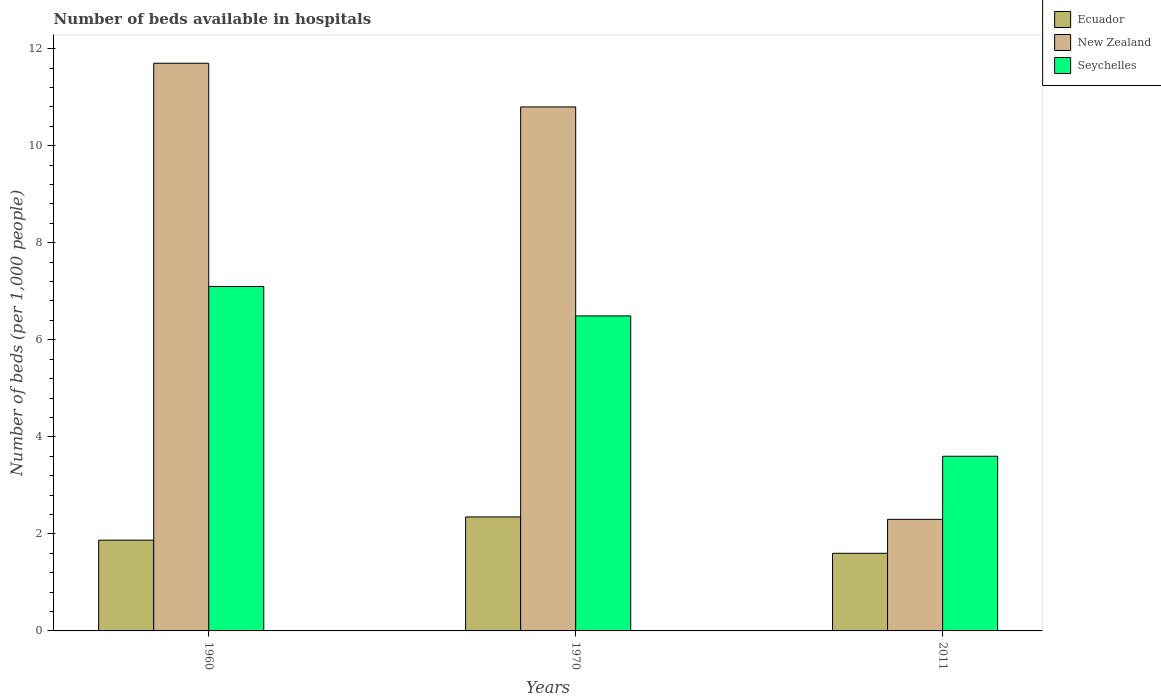How many different coloured bars are there?
Provide a short and direct response. 3. How many groups of bars are there?
Provide a succinct answer. 3. Are the number of bars per tick equal to the number of legend labels?
Provide a succinct answer. Yes. How many bars are there on the 1st tick from the left?
Your response must be concise. 3. How many bars are there on the 1st tick from the right?
Provide a succinct answer. 3. What is the label of the 1st group of bars from the left?
Offer a very short reply. 1960. What is the number of beds in the hospiatls of in New Zealand in 1960?
Give a very brief answer. 11.7. Across all years, what is the maximum number of beds in the hospiatls of in Ecuador?
Offer a very short reply. 2.35. Across all years, what is the minimum number of beds in the hospiatls of in New Zealand?
Your answer should be compact. 2.3. In which year was the number of beds in the hospiatls of in Ecuador maximum?
Provide a short and direct response. 1970. In which year was the number of beds in the hospiatls of in Seychelles minimum?
Provide a short and direct response. 2011. What is the total number of beds in the hospiatls of in Ecuador in the graph?
Provide a succinct answer. 5.82. What is the difference between the number of beds in the hospiatls of in Seychelles in 1960 and that in 2011?
Your answer should be very brief. 3.5. What is the difference between the number of beds in the hospiatls of in New Zealand in 2011 and the number of beds in the hospiatls of in Ecuador in 1960?
Provide a succinct answer. 0.43. What is the average number of beds in the hospiatls of in Ecuador per year?
Your answer should be compact. 1.94. In the year 1960, what is the difference between the number of beds in the hospiatls of in Ecuador and number of beds in the hospiatls of in Seychelles?
Provide a short and direct response. -5.23. What is the ratio of the number of beds in the hospiatls of in New Zealand in 1960 to that in 2011?
Ensure brevity in your answer.  5.09. Is the difference between the number of beds in the hospiatls of in Ecuador in 1960 and 2011 greater than the difference between the number of beds in the hospiatls of in Seychelles in 1960 and 2011?
Offer a terse response. No. What is the difference between the highest and the second highest number of beds in the hospiatls of in Ecuador?
Provide a short and direct response. 0.48. What is the difference between the highest and the lowest number of beds in the hospiatls of in New Zealand?
Your answer should be very brief. 9.4. What does the 2nd bar from the left in 1960 represents?
Ensure brevity in your answer.  New Zealand. What does the 3rd bar from the right in 1960 represents?
Your answer should be compact. Ecuador. Is it the case that in every year, the sum of the number of beds in the hospiatls of in Ecuador and number of beds in the hospiatls of in New Zealand is greater than the number of beds in the hospiatls of in Seychelles?
Offer a terse response. Yes. How many bars are there?
Give a very brief answer. 9. Are all the bars in the graph horizontal?
Your answer should be compact. No. What is the difference between two consecutive major ticks on the Y-axis?
Your response must be concise. 2. Are the values on the major ticks of Y-axis written in scientific E-notation?
Ensure brevity in your answer.  No. How many legend labels are there?
Offer a very short reply. 3. How are the legend labels stacked?
Ensure brevity in your answer.  Vertical. What is the title of the graph?
Ensure brevity in your answer.  Number of beds available in hospitals. What is the label or title of the X-axis?
Your response must be concise. Years. What is the label or title of the Y-axis?
Offer a very short reply. Number of beds (per 1,0 people). What is the Number of beds (per 1,000 people) in Ecuador in 1960?
Your answer should be compact. 1.87. What is the Number of beds (per 1,000 people) in New Zealand in 1960?
Provide a succinct answer. 11.7. What is the Number of beds (per 1,000 people) in Seychelles in 1960?
Offer a very short reply. 7.1. What is the Number of beds (per 1,000 people) of Ecuador in 1970?
Ensure brevity in your answer.  2.35. What is the Number of beds (per 1,000 people) in New Zealand in 1970?
Your answer should be compact. 10.8. What is the Number of beds (per 1,000 people) in Seychelles in 1970?
Your answer should be very brief. 6.49. What is the Number of beds (per 1,000 people) in New Zealand in 2011?
Ensure brevity in your answer.  2.3. What is the Number of beds (per 1,000 people) of Seychelles in 2011?
Make the answer very short. 3.6. Across all years, what is the maximum Number of beds (per 1,000 people) of Ecuador?
Your answer should be very brief. 2.35. Across all years, what is the maximum Number of beds (per 1,000 people) of New Zealand?
Ensure brevity in your answer.  11.7. Across all years, what is the maximum Number of beds (per 1,000 people) in Seychelles?
Make the answer very short. 7.1. Across all years, what is the minimum Number of beds (per 1,000 people) in Seychelles?
Offer a terse response. 3.6. What is the total Number of beds (per 1,000 people) in Ecuador in the graph?
Your response must be concise. 5.82. What is the total Number of beds (per 1,000 people) in New Zealand in the graph?
Provide a succinct answer. 24.8. What is the total Number of beds (per 1,000 people) in Seychelles in the graph?
Keep it short and to the point. 17.19. What is the difference between the Number of beds (per 1,000 people) in Ecuador in 1960 and that in 1970?
Your answer should be very brief. -0.48. What is the difference between the Number of beds (per 1,000 people) in Seychelles in 1960 and that in 1970?
Make the answer very short. 0.61. What is the difference between the Number of beds (per 1,000 people) of Ecuador in 1960 and that in 2011?
Keep it short and to the point. 0.27. What is the difference between the Number of beds (per 1,000 people) in Seychelles in 1960 and that in 2011?
Keep it short and to the point. 3.5. What is the difference between the Number of beds (per 1,000 people) of Ecuador in 1970 and that in 2011?
Offer a very short reply. 0.75. What is the difference between the Number of beds (per 1,000 people) of Seychelles in 1970 and that in 2011?
Ensure brevity in your answer.  2.89. What is the difference between the Number of beds (per 1,000 people) in Ecuador in 1960 and the Number of beds (per 1,000 people) in New Zealand in 1970?
Your response must be concise. -8.93. What is the difference between the Number of beds (per 1,000 people) in Ecuador in 1960 and the Number of beds (per 1,000 people) in Seychelles in 1970?
Ensure brevity in your answer.  -4.62. What is the difference between the Number of beds (per 1,000 people) of New Zealand in 1960 and the Number of beds (per 1,000 people) of Seychelles in 1970?
Your answer should be compact. 5.21. What is the difference between the Number of beds (per 1,000 people) in Ecuador in 1960 and the Number of beds (per 1,000 people) in New Zealand in 2011?
Make the answer very short. -0.43. What is the difference between the Number of beds (per 1,000 people) of Ecuador in 1960 and the Number of beds (per 1,000 people) of Seychelles in 2011?
Offer a very short reply. -1.73. What is the difference between the Number of beds (per 1,000 people) of Ecuador in 1970 and the Number of beds (per 1,000 people) of New Zealand in 2011?
Your answer should be compact. 0.05. What is the difference between the Number of beds (per 1,000 people) in Ecuador in 1970 and the Number of beds (per 1,000 people) in Seychelles in 2011?
Your response must be concise. -1.25. What is the difference between the Number of beds (per 1,000 people) of New Zealand in 1970 and the Number of beds (per 1,000 people) of Seychelles in 2011?
Your answer should be compact. 7.2. What is the average Number of beds (per 1,000 people) of Ecuador per year?
Your answer should be very brief. 1.94. What is the average Number of beds (per 1,000 people) of New Zealand per year?
Ensure brevity in your answer.  8.27. What is the average Number of beds (per 1,000 people) of Seychelles per year?
Give a very brief answer. 5.73. In the year 1960, what is the difference between the Number of beds (per 1,000 people) in Ecuador and Number of beds (per 1,000 people) in New Zealand?
Provide a short and direct response. -9.83. In the year 1960, what is the difference between the Number of beds (per 1,000 people) in Ecuador and Number of beds (per 1,000 people) in Seychelles?
Ensure brevity in your answer.  -5.23. In the year 1960, what is the difference between the Number of beds (per 1,000 people) of New Zealand and Number of beds (per 1,000 people) of Seychelles?
Offer a very short reply. 4.6. In the year 1970, what is the difference between the Number of beds (per 1,000 people) in Ecuador and Number of beds (per 1,000 people) in New Zealand?
Your response must be concise. -8.45. In the year 1970, what is the difference between the Number of beds (per 1,000 people) of Ecuador and Number of beds (per 1,000 people) of Seychelles?
Provide a short and direct response. -4.14. In the year 1970, what is the difference between the Number of beds (per 1,000 people) in New Zealand and Number of beds (per 1,000 people) in Seychelles?
Provide a short and direct response. 4.31. In the year 2011, what is the difference between the Number of beds (per 1,000 people) in Ecuador and Number of beds (per 1,000 people) in Seychelles?
Your response must be concise. -2. What is the ratio of the Number of beds (per 1,000 people) of Ecuador in 1960 to that in 1970?
Give a very brief answer. 0.8. What is the ratio of the Number of beds (per 1,000 people) in Seychelles in 1960 to that in 1970?
Your answer should be compact. 1.09. What is the ratio of the Number of beds (per 1,000 people) in Ecuador in 1960 to that in 2011?
Your answer should be very brief. 1.17. What is the ratio of the Number of beds (per 1,000 people) of New Zealand in 1960 to that in 2011?
Make the answer very short. 5.09. What is the ratio of the Number of beds (per 1,000 people) of Seychelles in 1960 to that in 2011?
Make the answer very short. 1.97. What is the ratio of the Number of beds (per 1,000 people) in Ecuador in 1970 to that in 2011?
Keep it short and to the point. 1.47. What is the ratio of the Number of beds (per 1,000 people) of New Zealand in 1970 to that in 2011?
Ensure brevity in your answer.  4.7. What is the ratio of the Number of beds (per 1,000 people) of Seychelles in 1970 to that in 2011?
Give a very brief answer. 1.8. What is the difference between the highest and the second highest Number of beds (per 1,000 people) of Ecuador?
Offer a very short reply. 0.48. What is the difference between the highest and the second highest Number of beds (per 1,000 people) of New Zealand?
Offer a terse response. 0.9. What is the difference between the highest and the second highest Number of beds (per 1,000 people) in Seychelles?
Make the answer very short. 0.61. What is the difference between the highest and the lowest Number of beds (per 1,000 people) in Ecuador?
Provide a succinct answer. 0.75. What is the difference between the highest and the lowest Number of beds (per 1,000 people) of Seychelles?
Keep it short and to the point. 3.5. 